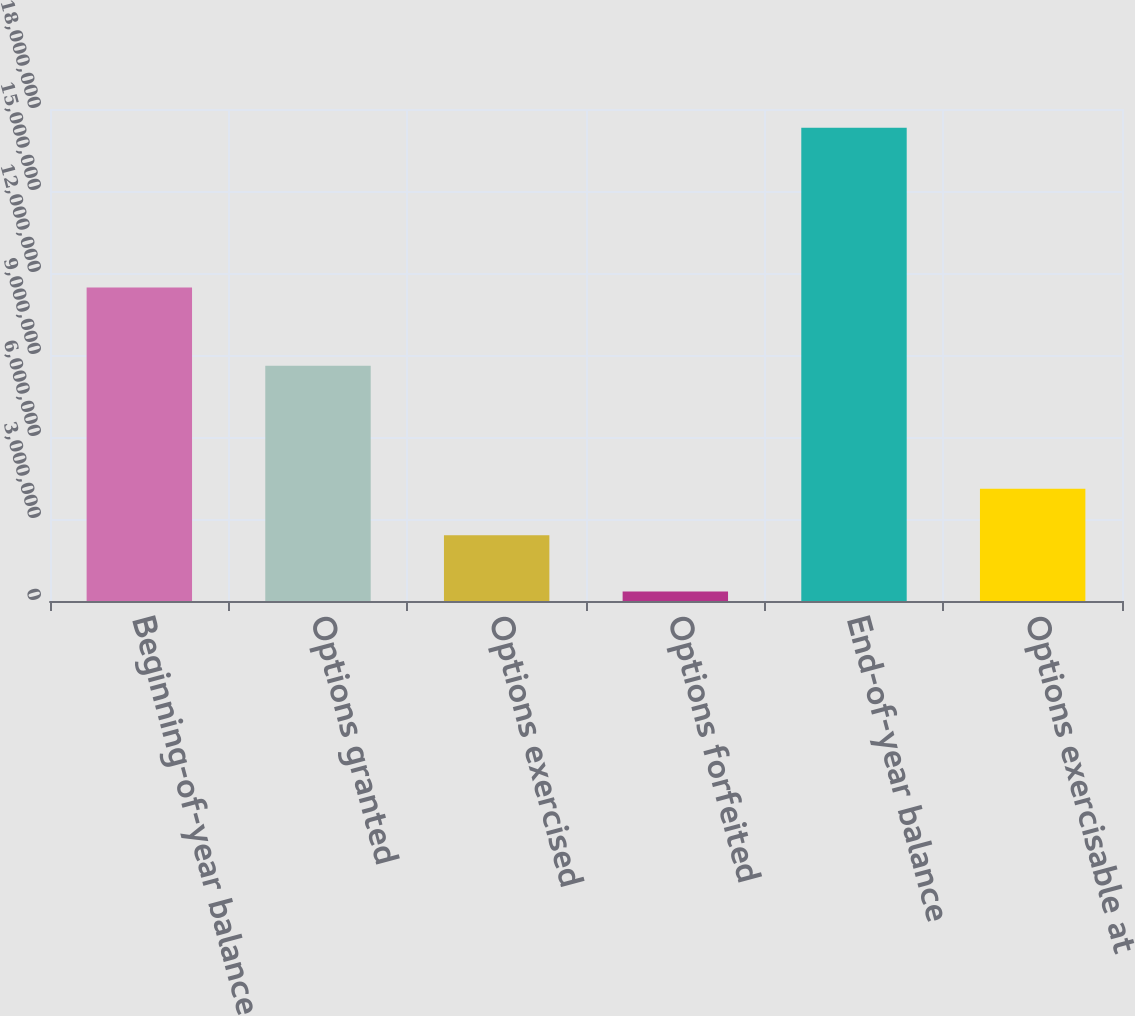<chart> <loc_0><loc_0><loc_500><loc_500><bar_chart><fcel>Beginning-of-year balance<fcel>Options granted<fcel>Options exercised<fcel>Options forfeited<fcel>End-of-year balance<fcel>Options exercisable at<nl><fcel>1.14683e+07<fcel>8.6023e+06<fcel>2.40778e+06<fcel>346017<fcel>1.73168e+07<fcel>4.10486e+06<nl></chart> 